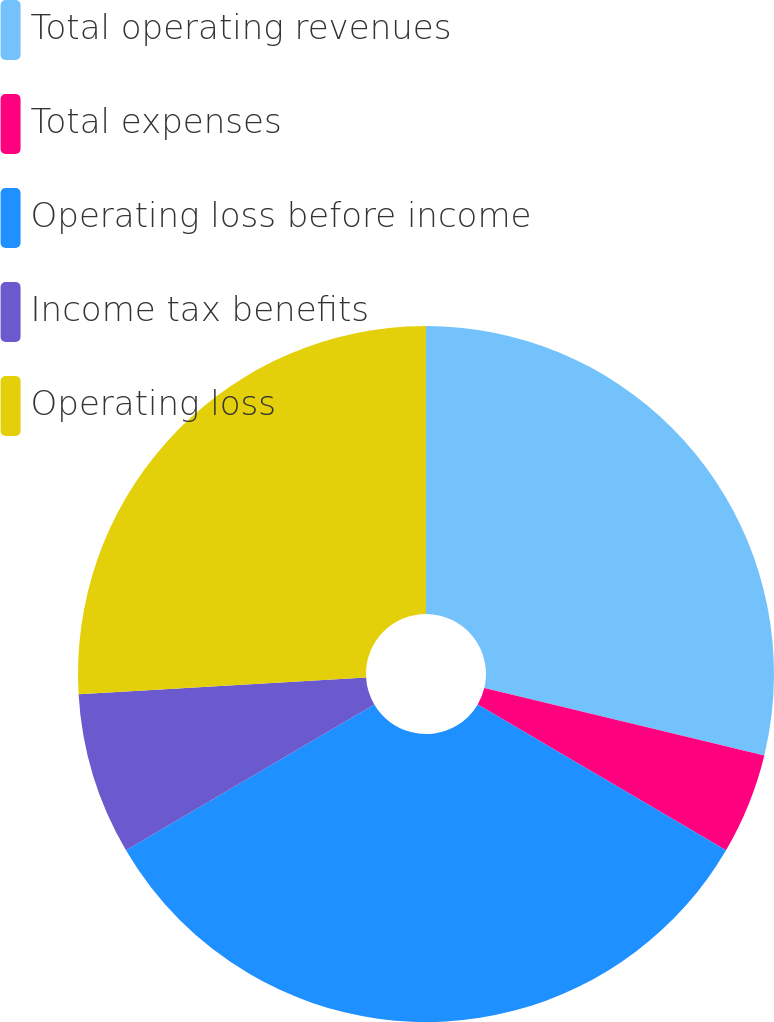<chart> <loc_0><loc_0><loc_500><loc_500><pie_chart><fcel>Total operating revenues<fcel>Total expenses<fcel>Operating loss before income<fcel>Income tax benefits<fcel>Operating loss<nl><fcel>28.77%<fcel>4.69%<fcel>33.09%<fcel>7.53%<fcel>25.93%<nl></chart> 